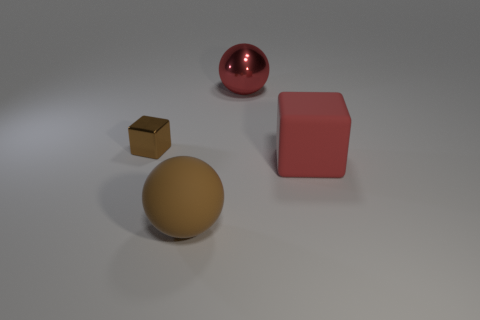Subtract 1 spheres. How many spheres are left? 1 Subtract all yellow cubes. Subtract all brown balls. How many cubes are left? 2 Subtract all gray balls. How many cyan blocks are left? 0 Subtract all small gray cubes. Subtract all brown objects. How many objects are left? 2 Add 4 big red blocks. How many big red blocks are left? 5 Add 1 large purple rubber blocks. How many large purple rubber blocks exist? 1 Add 1 large blue objects. How many objects exist? 5 Subtract 0 green blocks. How many objects are left? 4 